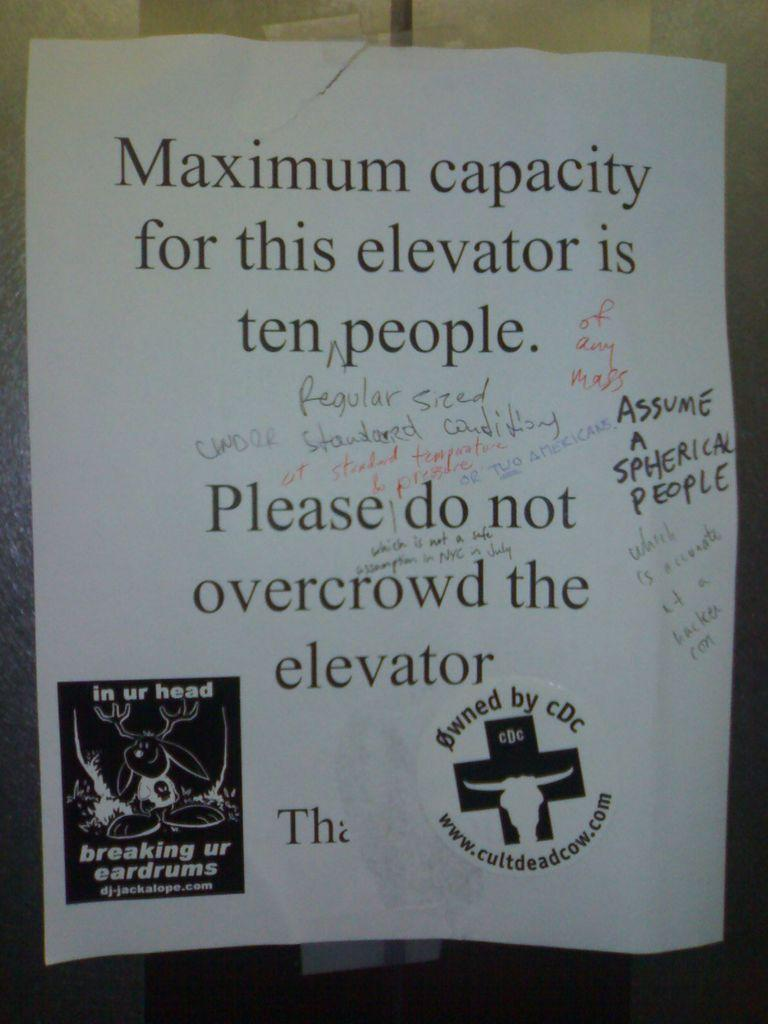Provide a one-sentence caption for the provided image. Paper that have maximum capacity for this elevator is ten people. 